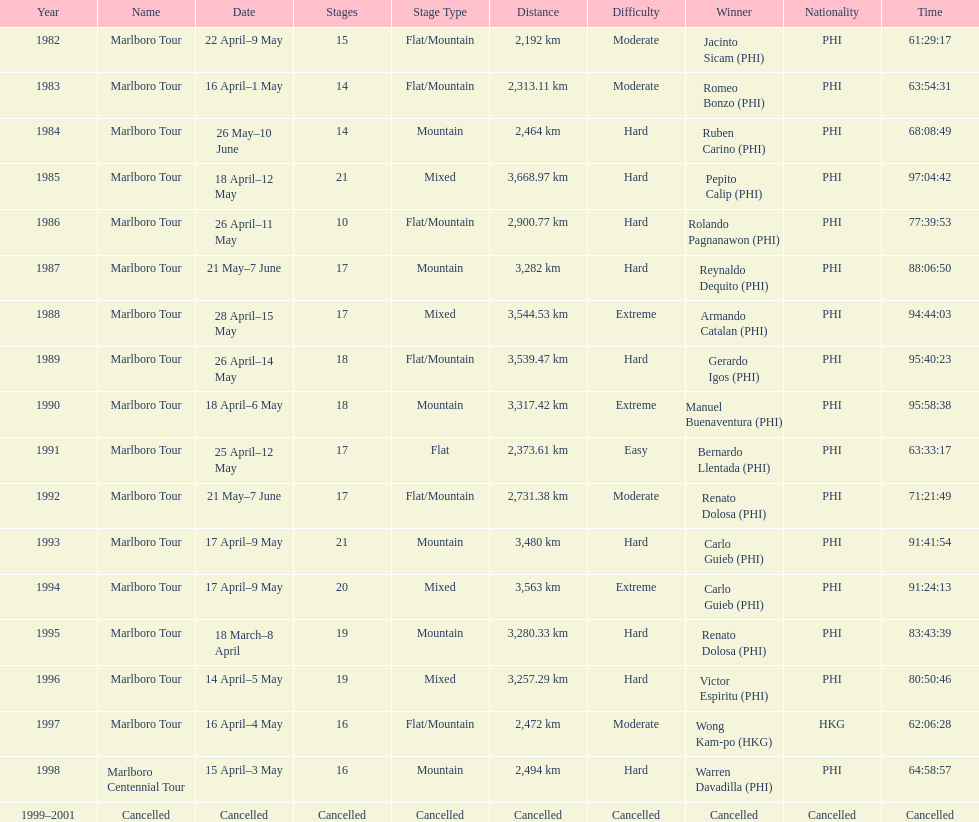What was the largest distance traveled for the marlboro tour? 3,668.97 km. 